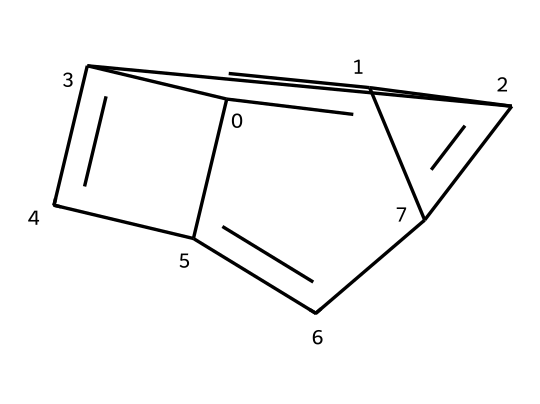How many carbon atoms are in the structure? The SMILES representation indicates there are multiple carbon atoms. Counting the 'C's in the representation, we find there are 6 carbon atoms total.
Answer: 6 What is the hybridization of the carbon atoms in graphene? In graphene, each carbon atom is bonded to three other carbon atoms, which results in a trigonal planar geometry around each carbon. This is indicative of sp2 hybridization.
Answer: sp2 What is the primary type of bond present in graphene? The primary bonding in graphene involves the sharing of electrons between carbon atoms, forming strong covalent bonds. In addition, there are delocalized π bonds due to overlapping p orbitals, which contribute to graphene's unique properties.
Answer: covalent What role does graphene's structure play in its conductivity? Graphene's structure allows for free movement of π electrons, enabling excellent electrical conductivity. The arrangement of carbon atoms in a two-dimensional plane results in high electron mobility.
Answer: high conductivity How does graphene's molecular arrangement affect its mechanical strength? The planar arrangement of carbon atoms creates a strong two-dimensional lattice structure, which is reinforced by covalent bonds. This strong bonding network contributes to graphene's exceptional tensile strength.
Answer: exceptional tensile strength What is the angle between the carbon-carbon bonds in graphene? In graphene, the angle between the sp2 hybridized carbon-carbon bonds is approximately 120 degrees, which is characteristic of a trigonal planar arrangement.
Answer: 120 degrees 